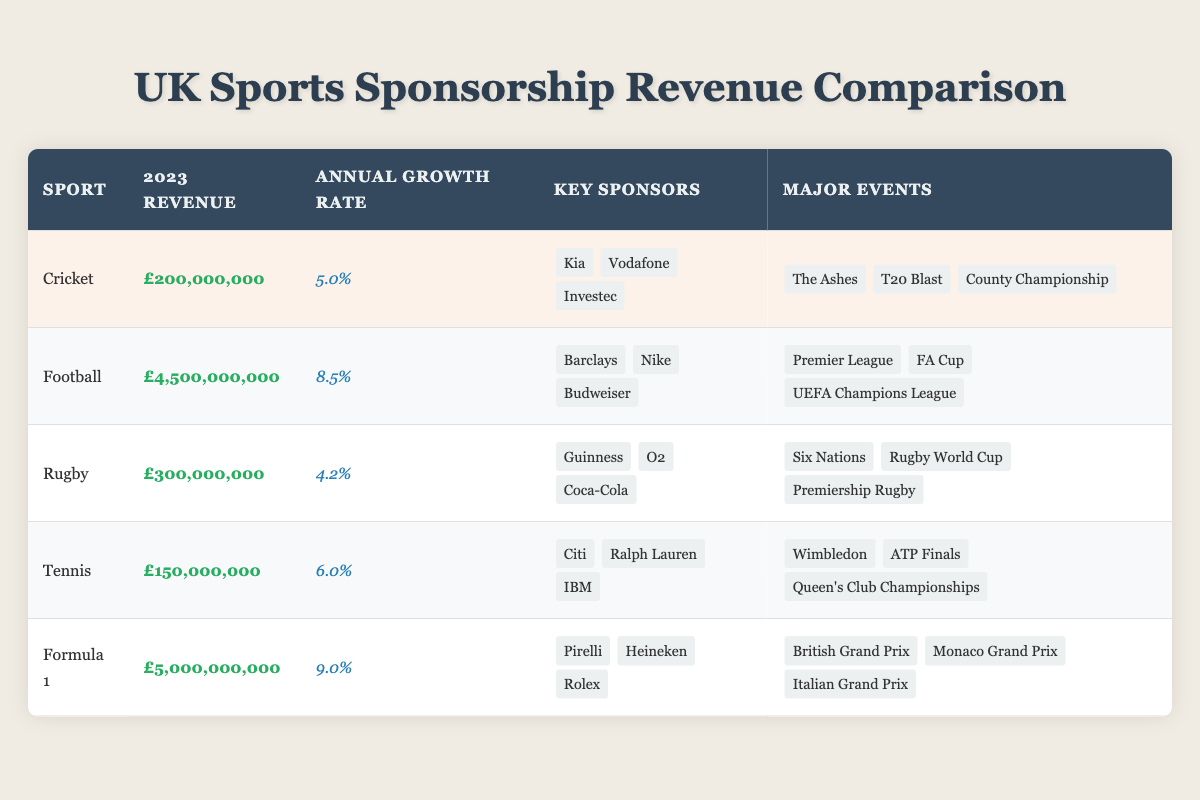What is the sponsorship revenue for Cricket in 2023? The table shows that the sponsorship revenue for Cricket in 2023 is listed directly as £200,000,000.
Answer: £200,000,000 Which sport has the highest sponsorship revenue in 2023? By comparing the values in the revenue column, Football has the highest sponsorship revenue at £4,500,000,000, which is greater than all other sports listed.
Answer: Football What is the annual growth rate for Rugby? The table indicates that the annual growth rate for Rugby is stated as 4.2%, which can be found in the growth rate column beside Rugby.
Answer: 4.2% How much more revenue does Formula 1 generate compared to Tennis? The 2023 revenue for Formula 1 is £5,000,000,000 and for Tennis it is £150,000,000; the difference is calculated by subtracting Tennis's revenue from Formula 1's revenue: £5,000,000,000 - £150,000,000 = £4,850,000,000.
Answer: £4,850,000,000 Which sport has the fastest annual growth rate? The annual growth rates for each sport show that Formula 1 has the highest growth rate at 9.0%, which is higher than all other sports’ growth rates listed.
Answer: Formula 1 Are all key sponsors for Cricket in 2023 financial institutions? The key sponsors for Cricket are Kia, Vodafone, and Investec. Kia and Vodafone are not strictly financial institutions; thus, the statement is false.
Answer: No What is the average sponsorship revenue of all sports listed in the table? The revenues for the sports are: Cricket (£200,000,000), Football (£4,500,000,000), Rugby (£300,000,000), Tennis (£150,000,000), and Formula 1 (£5,000,000,000). The total revenue is £200,000,000 + £4,500,000,000 + £300,000,000 + £150,000,000 + £5,000,000,000 = £10,150,000,000. There are 5 sports, so the average is £10,150,000,000 / 5 = £2,030,000,000.
Answer: £2,030,000,000 What percentage of the total sponsorship revenue does Cricket represent? First, we calculate the total sponsorship revenue (£10,150,000,000) as above. Then, we find the percentage of Cricket's revenue relative to the total: (£200,000,000 / £10,150,000,000) * 100 = 1.97%.
Answer: 1.97% Which sport has the lowest sponsorship revenue in 2023? The revenue figures show that Tennis has the lowest revenue at £150,000,000 when compared to all other sports.
Answer: Tennis Is the number of key sponsors for Cricket greater than that of Rugby? Cricket has 3 key sponsors while Rugby also has 3 key sponsors. Therefore, they are equal, and the statement is false.
Answer: No 